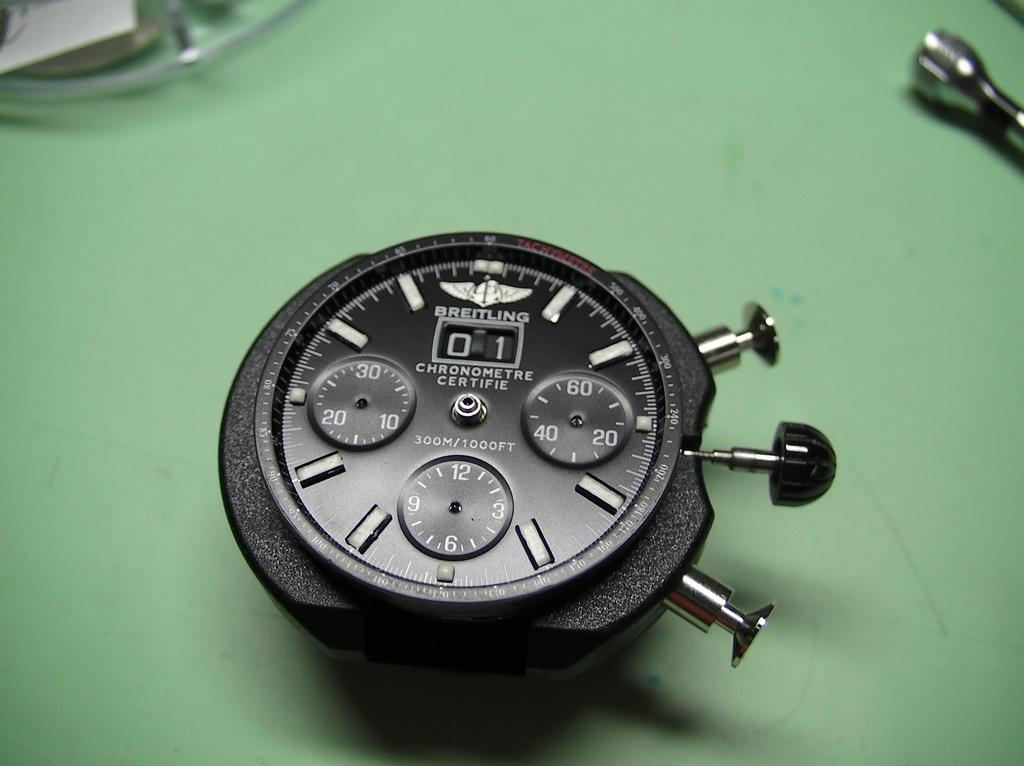Provide a one-sentence caption for the provided image. A Breitling watch face contains three small dials and a date indicator. 